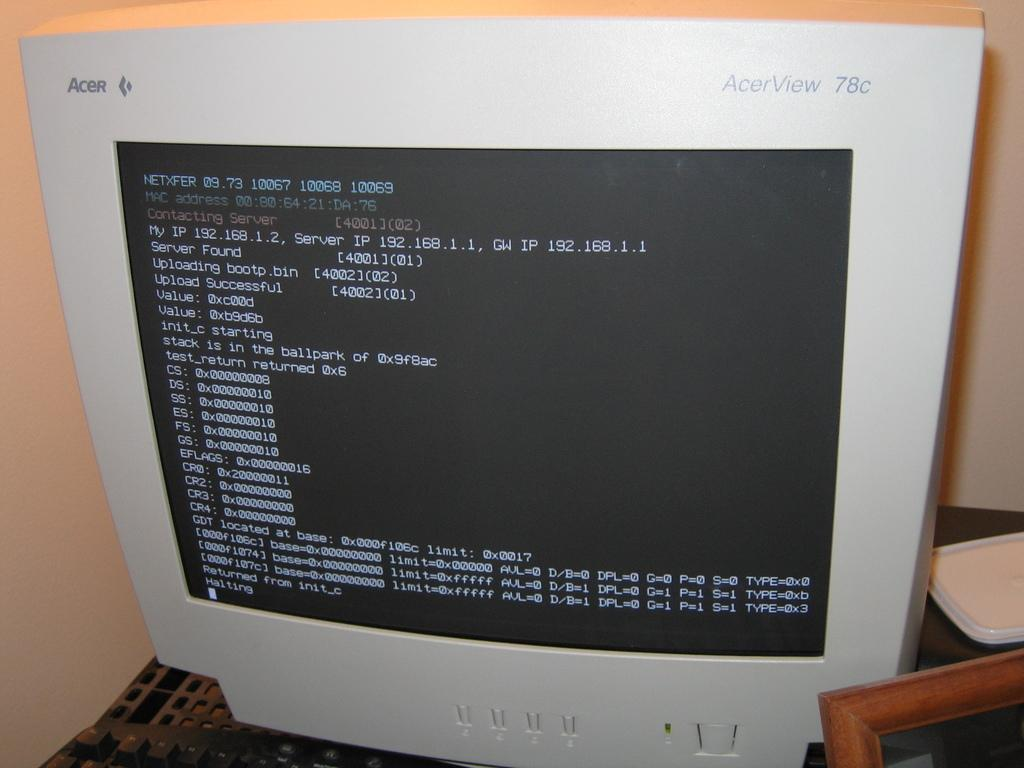<image>
Relay a brief, clear account of the picture shown. An Acer AcerView 78c computer monitor with a black screen with white writing. 